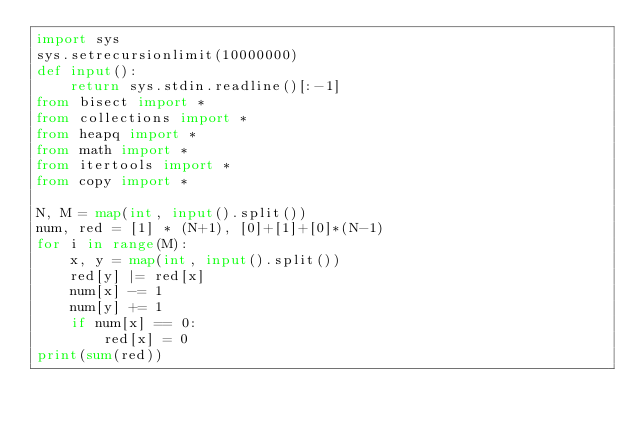Convert code to text. <code><loc_0><loc_0><loc_500><loc_500><_Python_>import sys
sys.setrecursionlimit(10000000)
def input():
    return sys.stdin.readline()[:-1]
from bisect import *
from collections import *
from heapq import *
from math import *
from itertools import *
from copy import *

N, M = map(int, input().split())
num, red = [1] * (N+1), [0]+[1]+[0]*(N-1)
for i in range(M):
    x, y = map(int, input().split())
    red[y] |= red[x]
    num[x] -= 1
    num[y] += 1
    if num[x] == 0:
        red[x] = 0
print(sum(red))
</code> 